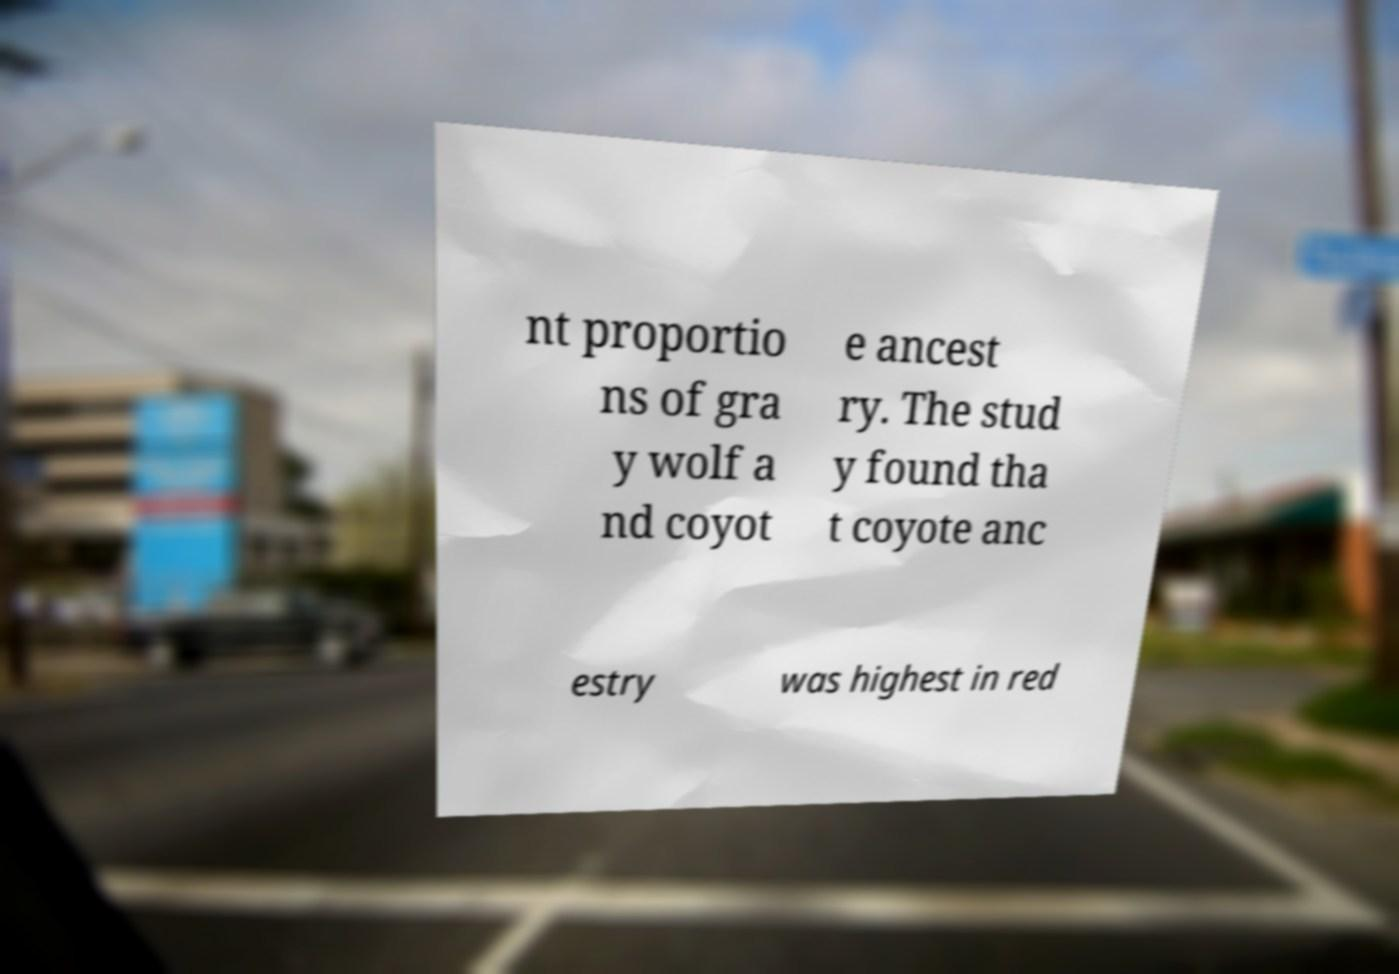What messages or text are displayed in this image? I need them in a readable, typed format. nt proportio ns of gra y wolf a nd coyot e ancest ry. The stud y found tha t coyote anc estry was highest in red 